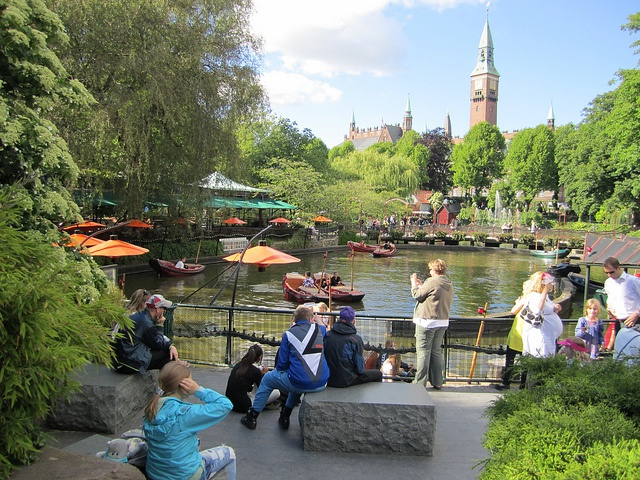Describe the objects in this image and their specific colors. I can see people in olive, blue, lightblue, and teal tones, people in olive, black, navy, gray, and darkblue tones, people in olive, gray, ivory, darkgray, and beige tones, people in olive, black, gray, darkblue, and navy tones, and people in olive, black, navy, gray, and darkblue tones in this image. 